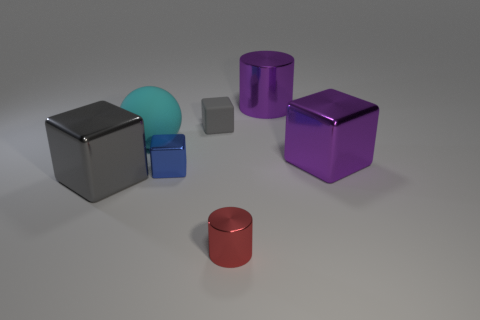Can you identify a color theme or palette that is predominant in this image? The color palette of the image leans towards cool tones, with the presence of several shades of blue and purple. The metallic sheen of some objects adds to the modern and clean aesthetic of the setup. 